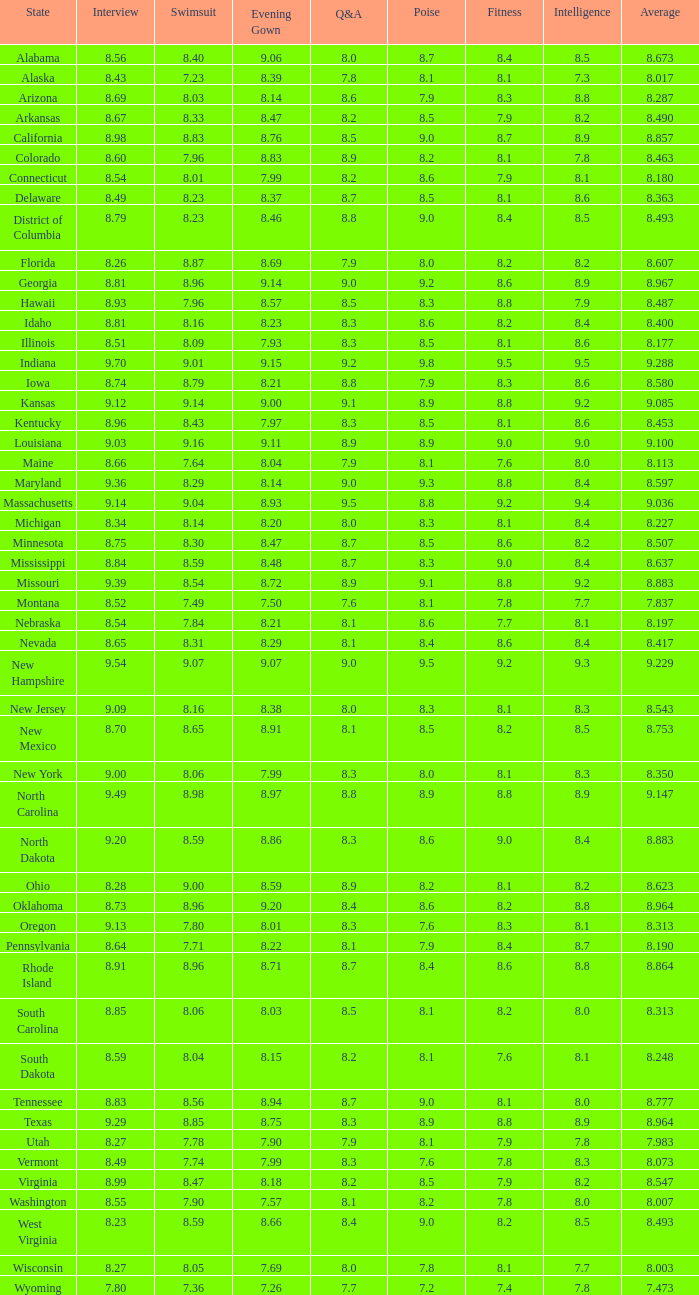Write the full table. {'header': ['State', 'Interview', 'Swimsuit', 'Evening Gown', 'Q&A', 'Poise', 'Fitness', 'Intelligence', 'Average'], 'rows': [['Alabama', '8.56', '8.40', '9.06', '8.0', '8.7', '8.4', '8.5', '8.673'], ['Alaska', '8.43', '7.23', '8.39', '7.8', '8.1', '8.1', '7.3', '8.017'], ['Arizona', '8.69', '8.03', '8.14', '8.6', '7.9', '8.3', '8.8', '8.287'], ['Arkansas', '8.67', '8.33', '8.47', '8.2', '8.5', '7.9', '8.2', '8.490'], ['California', '8.98', '8.83', '8.76', '8.5', '9.0', '8.7', '8.9', '8.857'], ['Colorado', '8.60', '7.96', '8.83', '8.9', '8.2', '8.1', '7.8', '8.463'], ['Connecticut', '8.54', '8.01', '7.99', '8.2', '8.6', '7.9', '8.1', '8.180'], ['Delaware', '8.49', '8.23', '8.37', '8.7', '8.5', '8.1', '8.6', '8.363'], ['District of Columbia', '8.79', '8.23', '8.46', '8.8', '9.0', '8.4', '8.5', '8.493'], ['Florida', '8.26', '8.87', '8.69', '7.9', '8.0', '8.2', '8.2', '8.607'], ['Georgia', '8.81', '8.96', '9.14', '9.0', '9.2', '8.6', '8.9', '8.967'], ['Hawaii', '8.93', '7.96', '8.57', '8.5', '8.3', '8.8', '7.9', '8.487'], ['Idaho', '8.81', '8.16', '8.23', '8.3', '8.6', '8.2', '8.4', '8.400'], ['Illinois', '8.51', '8.09', '7.93', '8.3', '8.5', '8.1', '8.6', '8.177'], ['Indiana', '9.70', '9.01', '9.15', '9.2', '9.8', '9.5', '9.5', '9.288'], ['Iowa', '8.74', '8.79', '8.21', '8.8', '7.9', '8.3', '8.6', '8.580'], ['Kansas', '9.12', '9.14', '9.00', '9.1', '8.9', '8.8', '9.2', '9.085'], ['Kentucky', '8.96', '8.43', '7.97', '8.3', '8.5', '8.1', '8.6', '8.453'], ['Louisiana', '9.03', '9.16', '9.11', '8.9', '8.9', '9.0', '9.0', '9.100'], ['Maine', '8.66', '7.64', '8.04', '7.9', '8.1', '7.6', '8.0', '8.113'], ['Maryland', '9.36', '8.29', '8.14', '9.0', '9.3', '8.8', '8.4', '8.597'], ['Massachusetts', '9.14', '9.04', '8.93', '9.5', '8.8', '9.2', '9.4', '9.036'], ['Michigan', '8.34', '8.14', '8.20', '8.0', '8.3', '8.1', '8.4', '8.227'], ['Minnesota', '8.75', '8.30', '8.47', '8.7', '8.5', '8.6', '8.2', '8.507'], ['Mississippi', '8.84', '8.59', '8.48', '8.7', '8.3', '9.0', '8.4', '8.637'], ['Missouri', '9.39', '8.54', '8.72', '8.9', '9.1', '8.8', '9.2', '8.883'], ['Montana', '8.52', '7.49', '7.50', '7.6', '8.1', '7.8', '7.7', '7.837'], ['Nebraska', '8.54', '7.84', '8.21', '8.1', '8.6', '7.7', '8.1', '8.197'], ['Nevada', '8.65', '8.31', '8.29', '8.1', '8.4', '8.6', '8.4', '8.417'], ['New Hampshire', '9.54', '9.07', '9.07', '9.0', '9.5', '9.2', '9.3', '9.229'], ['New Jersey', '9.09', '8.16', '8.38', '8.0', '8.3', '8.1', '8.3', '8.543'], ['New Mexico', '8.70', '8.65', '8.91', '8.1', '8.5', '8.2', '8.5', '8.753'], ['New York', '9.00', '8.06', '7.99', '8.3', '8.0', '8.1', '8.3', '8.350'], ['North Carolina', '9.49', '8.98', '8.97', '8.8', '8.9', '8.8', '8.9', '9.147'], ['North Dakota', '9.20', '8.59', '8.86', '8.3', '8.6', '9.0', '8.4', '8.883'], ['Ohio', '8.28', '9.00', '8.59', '8.9', '8.2', '8.1', '8.2', '8.623'], ['Oklahoma', '8.73', '8.96', '9.20', '8.4', '8.6', '8.2', '8.8', '8.964'], ['Oregon', '9.13', '7.80', '8.01', '8.3', '7.6', '8.3', '8.1', '8.313'], ['Pennsylvania', '8.64', '7.71', '8.22', '8.1', '7.9', '8.4', '8.7', '8.190'], ['Rhode Island', '8.91', '8.96', '8.71', '8.7', '8.4', '8.6', '8.8', '8.864'], ['South Carolina', '8.85', '8.06', '8.03', '8.5', '8.1', '8.2', '8.0', '8.313'], ['South Dakota', '8.59', '8.04', '8.15', '8.2', '8.1', '7.6', '8.1', '8.248'], ['Tennessee', '8.83', '8.56', '8.94', '8.7', '9.0', '8.1', '8.0', '8.777'], ['Texas', '9.29', '8.85', '8.75', '8.3', '8.9', '8.8', '8.9', '8.964'], ['Utah', '8.27', '7.78', '7.90', '7.9', '8.1', '7.9', '7.8', '7.983'], ['Vermont', '8.49', '7.74', '7.99', '8.3', '7.6', '7.8', '8.3', '8.073'], ['Virginia', '8.99', '8.47', '8.18', '8.2', '8.5', '7.9', '8.2', '8.547'], ['Washington', '8.55', '7.90', '7.57', '8.1', '8.2', '7.8', '8.0', '8.007'], ['West Virginia', '8.23', '8.59', '8.66', '8.4', '9.0', '8.2', '8.5', '8.493'], ['Wisconsin', '8.27', '8.05', '7.69', '8.0', '7.8', '8.1', '7.7', '8.003'], ['Wyoming', '7.80', '7.36', '7.26', '7.7', '7.2', '7.4', '7.8', '7.473']]} Name the state with an evening gown more than 8.86 and interview less than 8.7 and swimsuit less than 8.96 Alabama. 